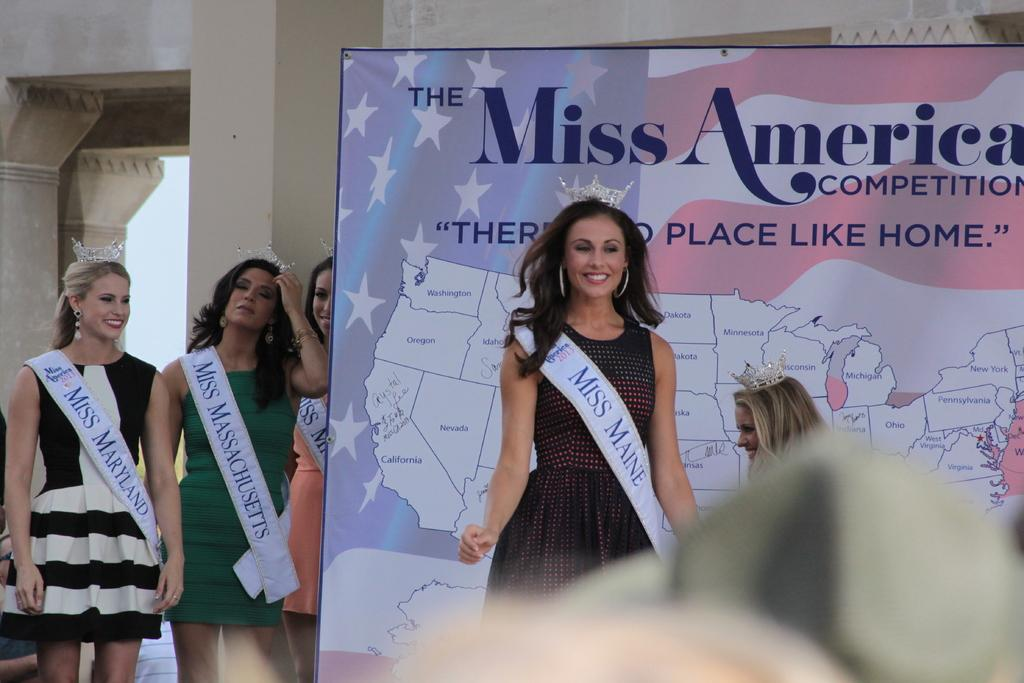Provide a one-sentence caption for the provided image. Five Miss America contestants are on the stage. 